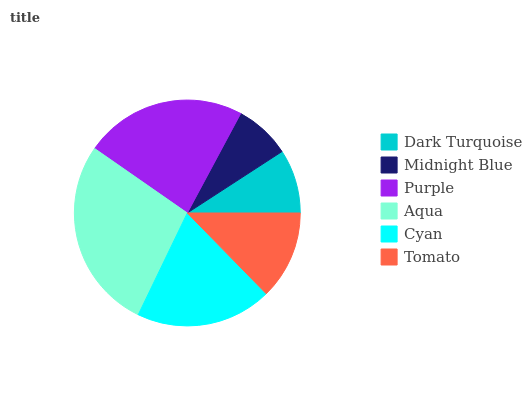Is Midnight Blue the minimum?
Answer yes or no. Yes. Is Aqua the maximum?
Answer yes or no. Yes. Is Purple the minimum?
Answer yes or no. No. Is Purple the maximum?
Answer yes or no. No. Is Purple greater than Midnight Blue?
Answer yes or no. Yes. Is Midnight Blue less than Purple?
Answer yes or no. Yes. Is Midnight Blue greater than Purple?
Answer yes or no. No. Is Purple less than Midnight Blue?
Answer yes or no. No. Is Cyan the high median?
Answer yes or no. Yes. Is Tomato the low median?
Answer yes or no. Yes. Is Aqua the high median?
Answer yes or no. No. Is Cyan the low median?
Answer yes or no. No. 